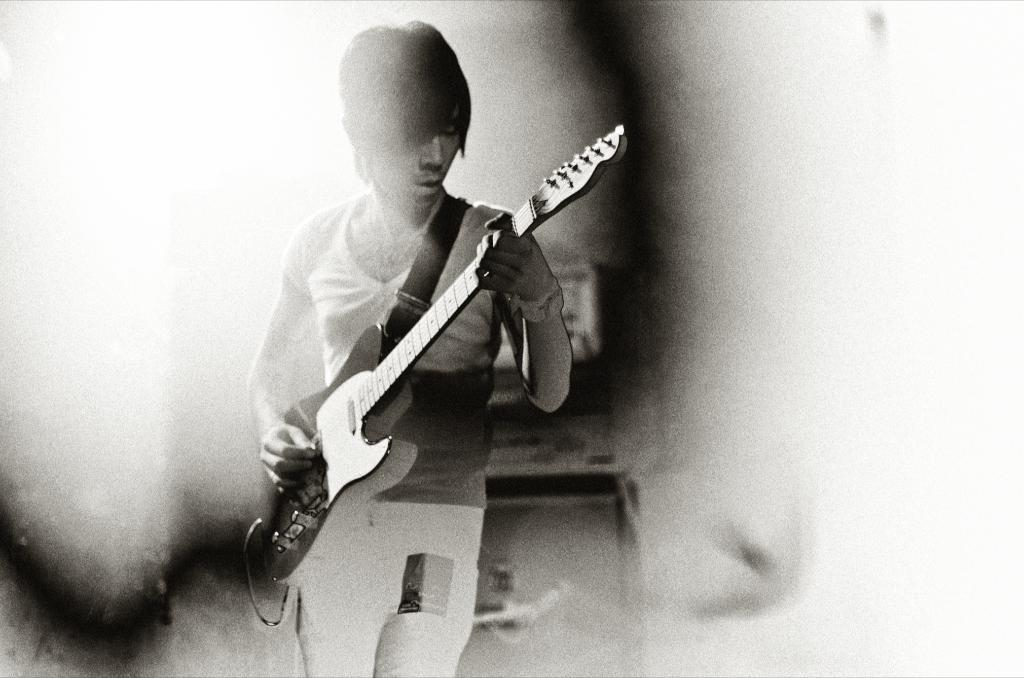Who is the main subject in the image? There is a boy in the image. What is the boy doing in the image? The boy is standing in the image. What is the boy holding in the image? The boy is holding a music instrument in the image. What is the color of the music instrument? The music instrument is black in color. How many lizards can be seen crawling on the music instrument in the image? There are no lizards present in the image, and therefore none can be seen crawling on the music instrument. What type of soup is being served in the image? There is no soup present in the image. 